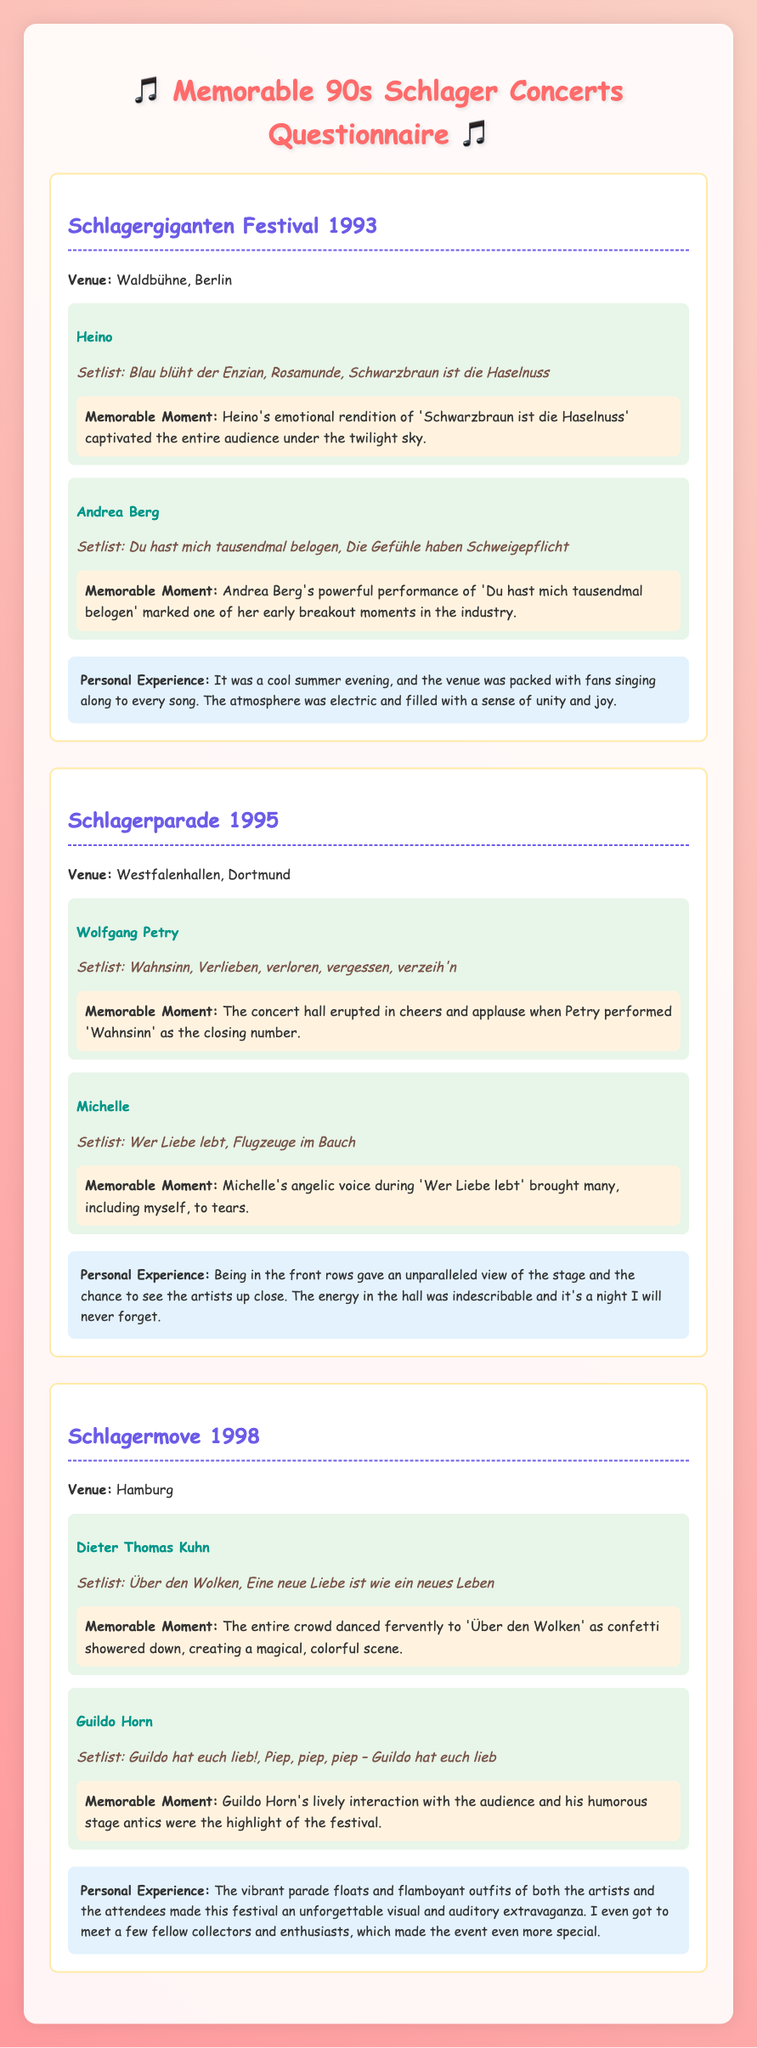What year did the Schlagergiganten Festival take place? The document states the event's name and specifies that it occurred in 1993.
Answer: 1993 Where was the Schlagerparade held? The venue for the Schlagerparade is mentioned in the document, indicating it took place in Dortmund.
Answer: Dortmund Who performed "Blau blüht der Enzian"? The document lists the artists performing at the Schlagergiganten Festival and clearly states that Heino performed this song.
Answer: Heino What was a memorable moment from the performance of Wolfgang Petry? The document provides a specific memorable moment associated with Wolfgang Petry's performance, indicating that the audience erupted in cheers when he performed "Wahnsinn."
Answer: Cheering audience Which song did Dieter Thomas Kuhn perform that had a confetti shower? The document notes that during the performance of "Über den Wolken," confetti showered down, creating a magical scene.
Answer: Über den Wolken What is the common theme of the events described in the document? The events all revolve around German schlager music concerts and festivals, highlighting performances from various artists.
Answer: German schlager music How did the atmosphere feel at the Schlagergiganten Festival? The document describes the atmosphere as electric and filled with unity and joy, creating a strong personal experience.
Answer: Electric Which artist's performance caused many to tear up? The document highlights that Michelle's angelic voice during "Wer Liebe lebt" brought many to tears.
Answer: Michelle 